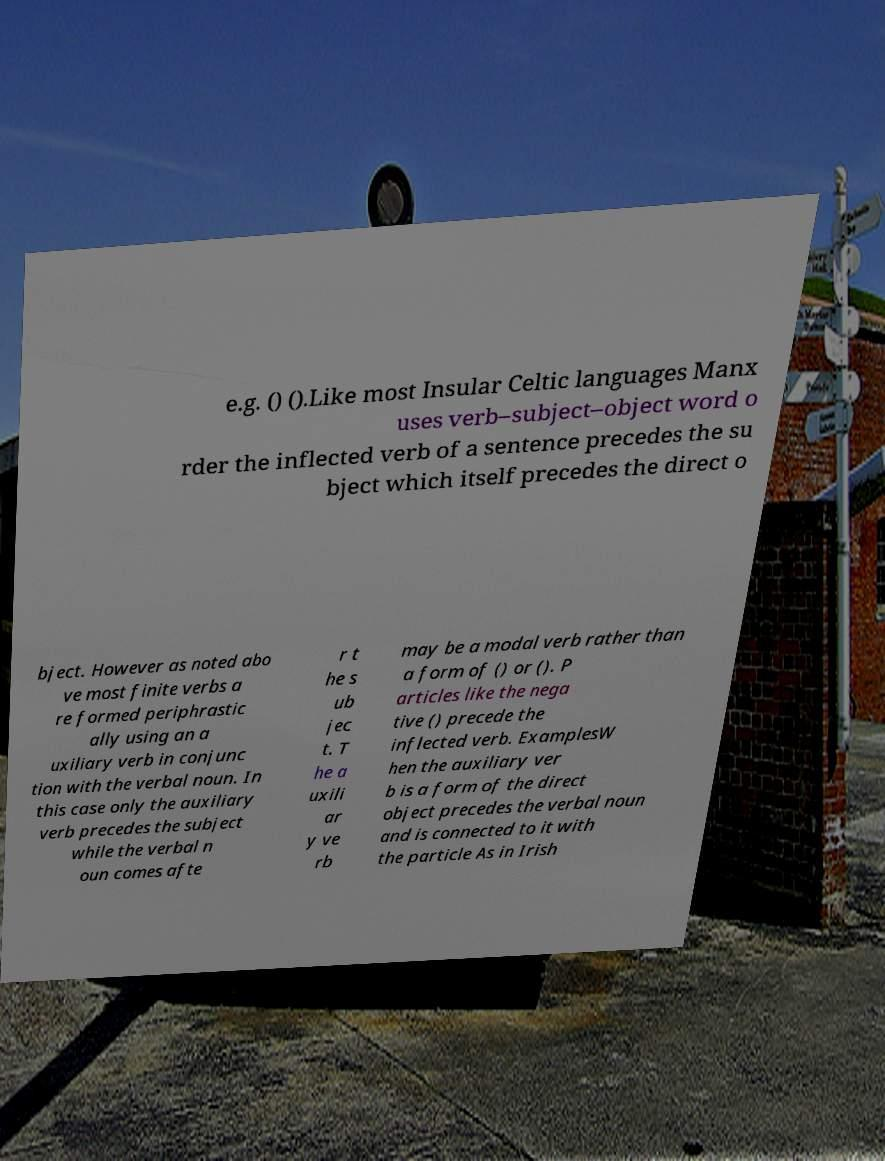Can you read and provide the text displayed in the image?This photo seems to have some interesting text. Can you extract and type it out for me? e.g. () ().Like most Insular Celtic languages Manx uses verb–subject–object word o rder the inflected verb of a sentence precedes the su bject which itself precedes the direct o bject. However as noted abo ve most finite verbs a re formed periphrastic ally using an a uxiliary verb in conjunc tion with the verbal noun. In this case only the auxiliary verb precedes the subject while the verbal n oun comes afte r t he s ub jec t. T he a uxili ar y ve rb may be a modal verb rather than a form of () or (). P articles like the nega tive () precede the inflected verb. ExamplesW hen the auxiliary ver b is a form of the direct object precedes the verbal noun and is connected to it with the particle As in Irish 